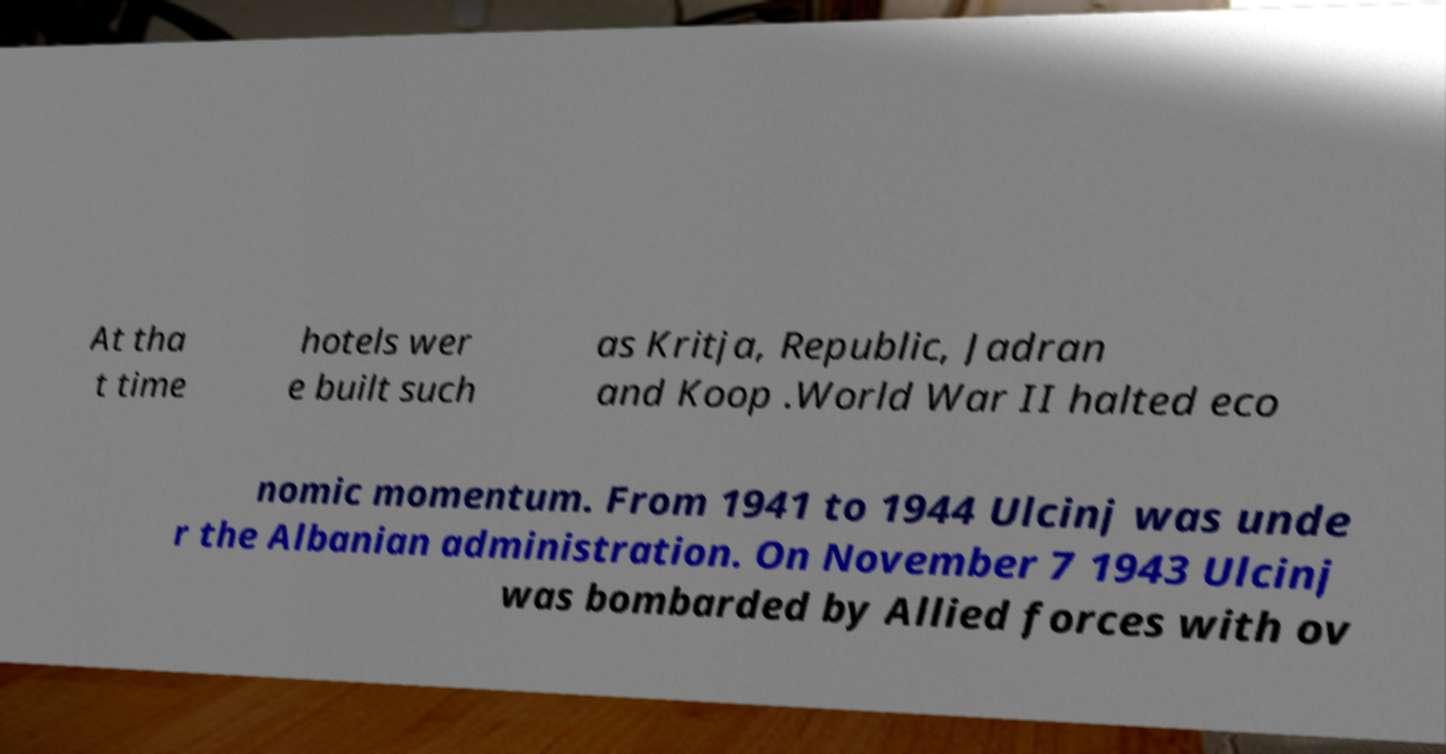Can you read and provide the text displayed in the image?This photo seems to have some interesting text. Can you extract and type it out for me? At tha t time hotels wer e built such as Kritja, Republic, Jadran and Koop .World War II halted eco nomic momentum. From 1941 to 1944 Ulcinj was unde r the Albanian administration. On November 7 1943 Ulcinj was bombarded by Allied forces with ov 